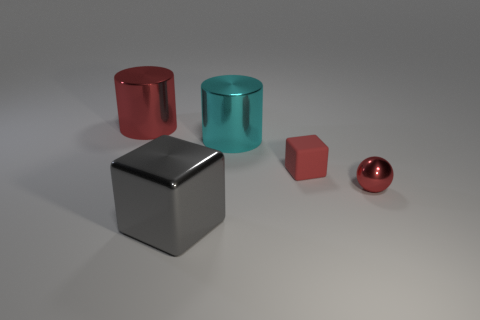Add 3 metallic spheres. How many objects exist? 8 Subtract all cyan cylinders. How many cylinders are left? 1 Add 3 large metallic blocks. How many large metallic blocks exist? 4 Subtract 0 blue cylinders. How many objects are left? 5 Subtract all cubes. How many objects are left? 3 Subtract all yellow cubes. Subtract all yellow balls. How many cubes are left? 2 Subtract all large cylinders. Subtract all small metallic objects. How many objects are left? 2 Add 5 cyan shiny things. How many cyan shiny things are left? 6 